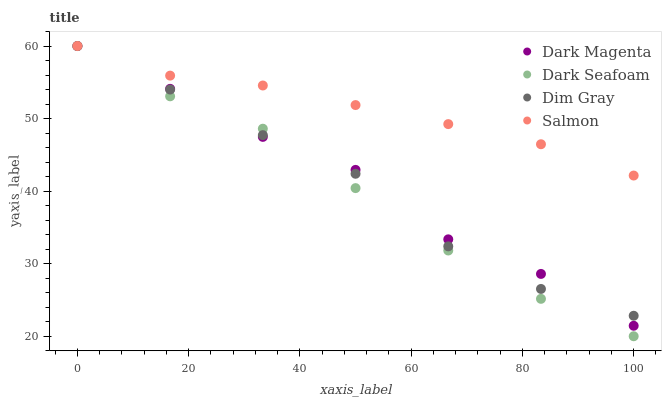Does Dark Seafoam have the minimum area under the curve?
Answer yes or no. Yes. Does Salmon have the maximum area under the curve?
Answer yes or no. Yes. Does Dim Gray have the minimum area under the curve?
Answer yes or no. No. Does Dim Gray have the maximum area under the curve?
Answer yes or no. No. Is Salmon the smoothest?
Answer yes or no. Yes. Is Dark Magenta the roughest?
Answer yes or no. Yes. Is Dim Gray the smoothest?
Answer yes or no. No. Is Dim Gray the roughest?
Answer yes or no. No. Does Dark Seafoam have the lowest value?
Answer yes or no. Yes. Does Dim Gray have the lowest value?
Answer yes or no. No. Does Dark Magenta have the highest value?
Answer yes or no. Yes. Does Dim Gray have the highest value?
Answer yes or no. No. Is Dim Gray less than Salmon?
Answer yes or no. Yes. Is Salmon greater than Dim Gray?
Answer yes or no. Yes. Does Dark Seafoam intersect Dark Magenta?
Answer yes or no. Yes. Is Dark Seafoam less than Dark Magenta?
Answer yes or no. No. Is Dark Seafoam greater than Dark Magenta?
Answer yes or no. No. Does Dim Gray intersect Salmon?
Answer yes or no. No. 